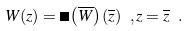Convert formula to latex. <formula><loc_0><loc_0><loc_500><loc_500>W ( z ) = \Omega \left ( \overline { W } \right ) ( \overline { z } ) \ , z = \overline { z } \ .</formula> 